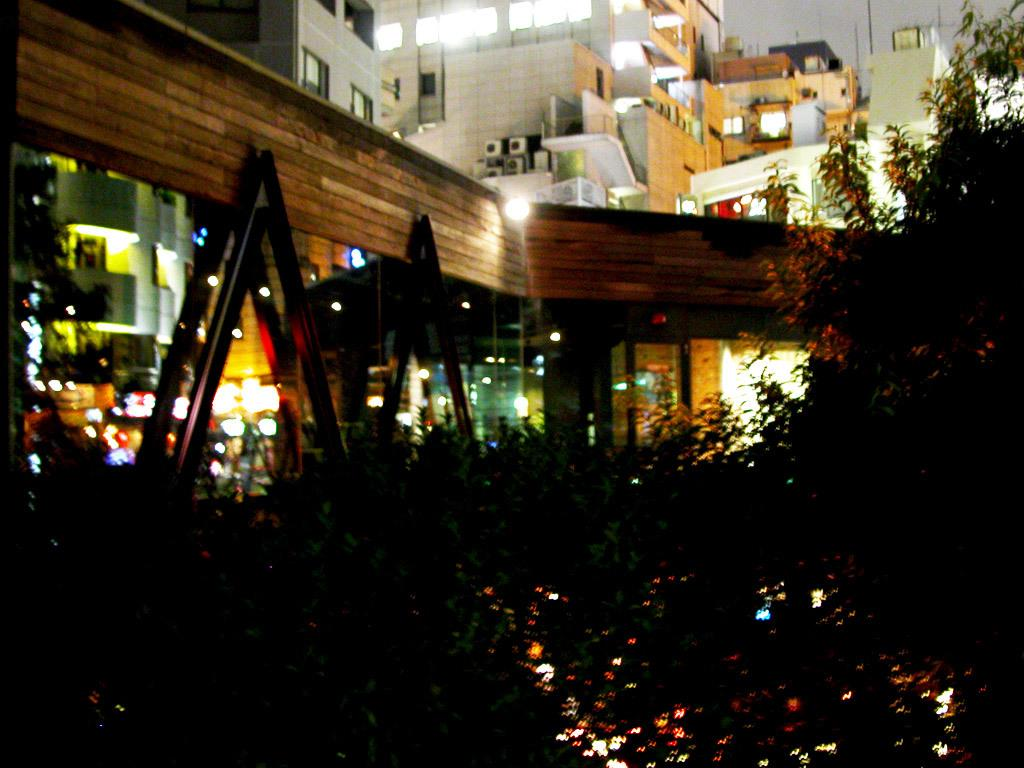What type of lights are present at the bottom of the image? There are lights on the trees at the bottom of the image. What structures have lights at the back side of the image? There are buildings with lights at the back side of the image. How does the statement "I love ice cream" relate to the image? The statement "I love ice cream" does not relate to the image, as there is no mention of ice cream or any related objects in the provided facts. 